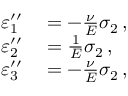Convert formula to latex. <formula><loc_0><loc_0><loc_500><loc_500>\begin{array} { r l } { \varepsilon _ { 1 } ^ { \prime \prime } } & = - { \frac { \nu } { E } } \sigma _ { 2 } \, , } \\ { \varepsilon _ { 2 } ^ { \prime \prime } } & = { \frac { 1 } { E } } \sigma _ { 2 } \, , } \\ { \varepsilon _ { 3 } ^ { \prime \prime } } & = - { \frac { \nu } { E } } \sigma _ { 2 } \, , } \end{array}</formula> 